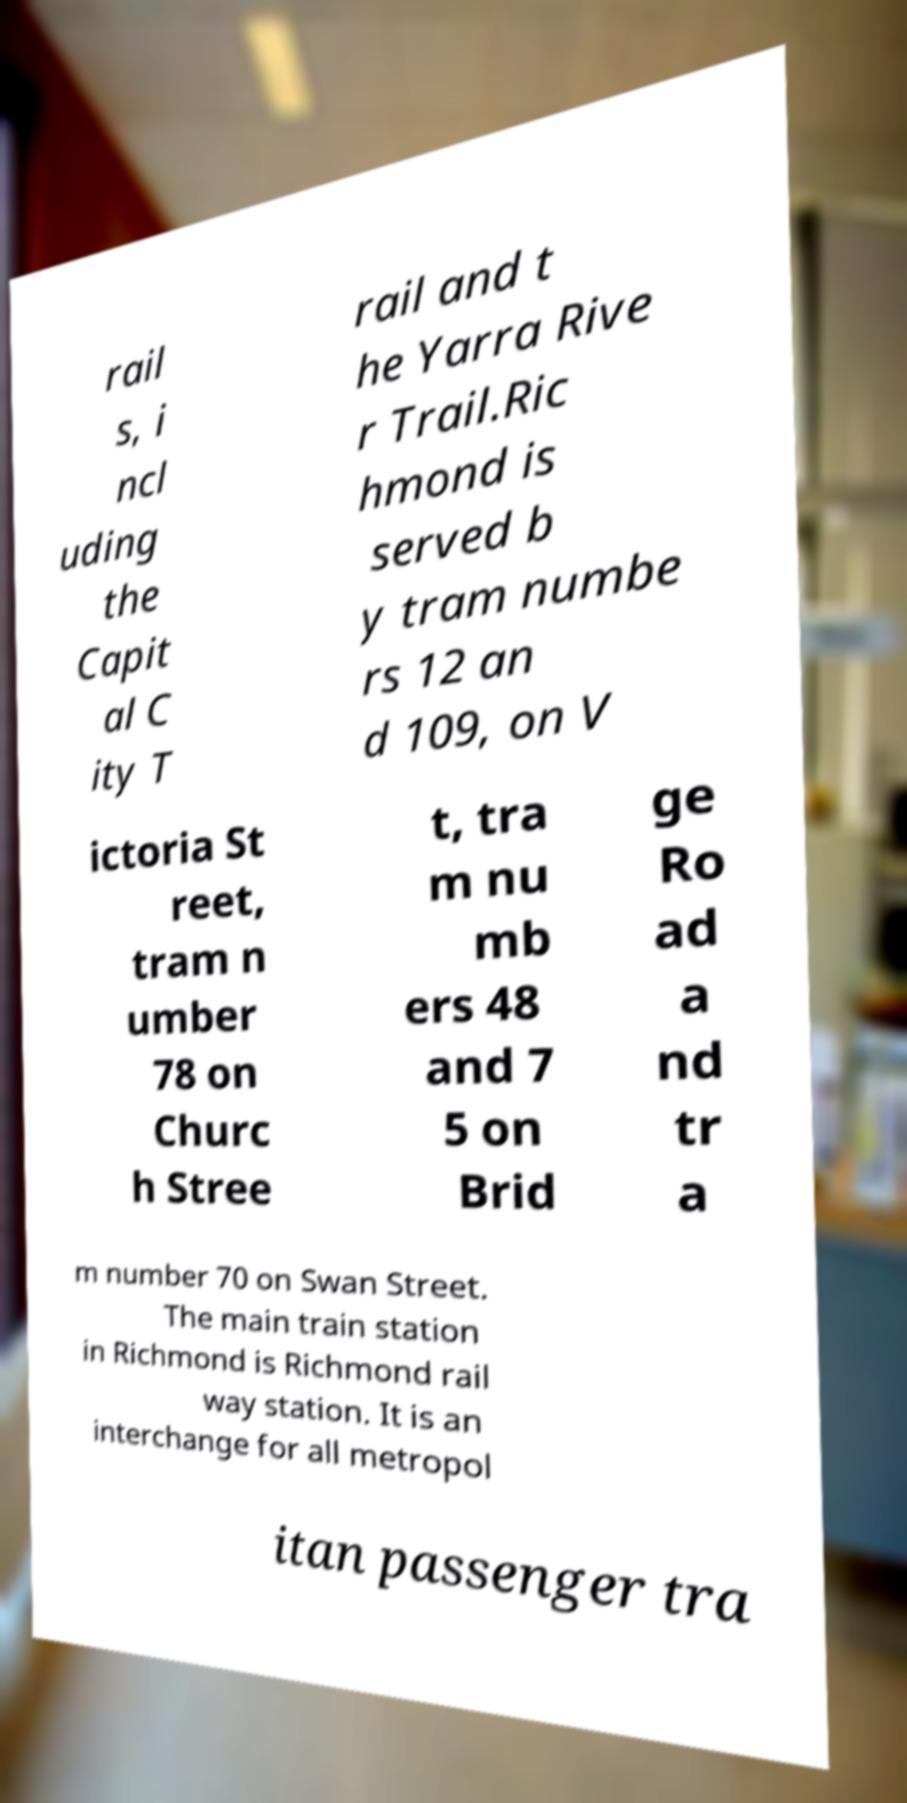I need the written content from this picture converted into text. Can you do that? rail s, i ncl uding the Capit al C ity T rail and t he Yarra Rive r Trail.Ric hmond is served b y tram numbe rs 12 an d 109, on V ictoria St reet, tram n umber 78 on Churc h Stree t, tra m nu mb ers 48 and 7 5 on Brid ge Ro ad a nd tr a m number 70 on Swan Street. The main train station in Richmond is Richmond rail way station. It is an interchange for all metropol itan passenger tra 